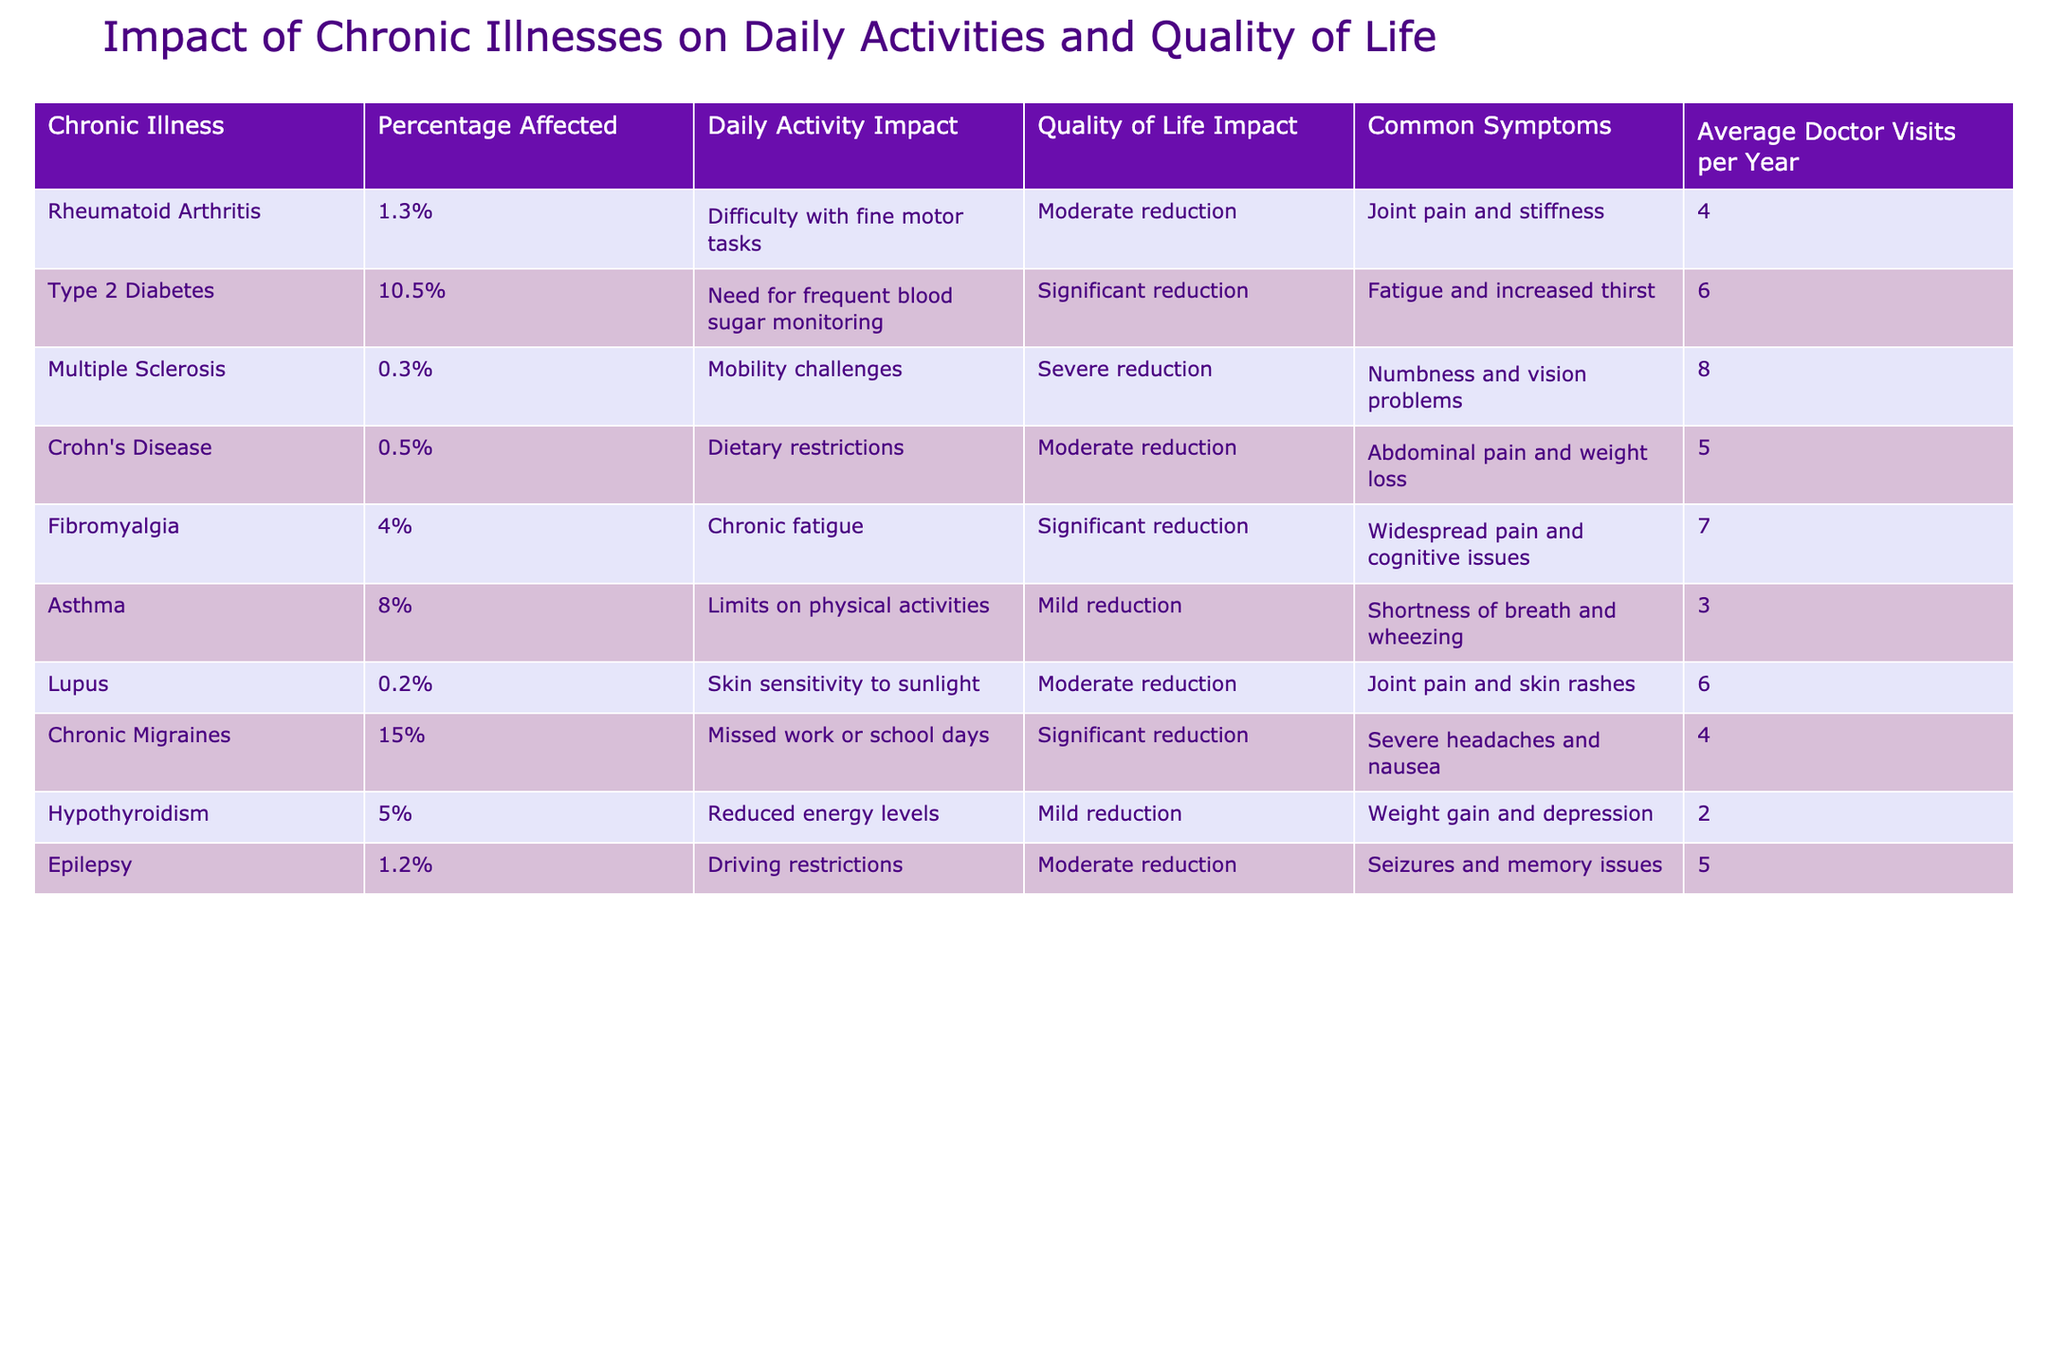What percentage of individuals with chronic migraines experience a significant reduction in quality of life? The table shows that 15% of individuals with chronic migraines are significantly affected in their quality of life.
Answer: 15% Which chronic illness has the lowest percentage affected? The table indicates that lupus has the lowest percentage affected at 0.2%.
Answer: 0.2% How many average doctor visits does a person with Type 2 Diabetes have per year? According to the table, individuals with Type 2 Diabetes make an average of 6 doctor visits per year.
Answer: 6 What is the average daily activity impact for people with Fibromyalgia compared to those with Asthma? Fibromyalgia has a significant reduction, while Asthma has a mild reduction in daily activity impact. Thus, Fibromyalgia has a higher impact.
Answer: Higher impact for Fibromyalgia Does having Epilepsy result in a severe reduction in daily activity? The table shows that Epilepsy results in a moderate reduction in daily activity, so the statement is false.
Answer: False What is the average percentage affected across all chronic illnesses presented in the table? To find the average percentage affected, we sum the percentages: 1.3 + 10.5 + 0.3 + 0.5 + 4 + 8 + 0.2 + 15 + 5 + 1.2 = 42.8%, and then divide by the count of diseases (10), resulting in an average of 4.28%.
Answer: 4.28% What percentage of individuals with Crohn's Disease report a moderate reduction in quality of life? The table states that individuals with Crohn's Disease experience a moderate reduction in quality of life, but it does not specify a percentage, as the overall affected percentage is 0.5%.
Answer: Not specified Which chronic illness causes the most doctor visits per year, and what is that number? The table indicates that Multiple Sclerosis has the most doctor visits at 8 per year.
Answer: 8 Is the impact on daily activities for Lupus higher or lower than for Type 2 Diabetes? Lupus has a moderate reduction while Type 2 Diabetes has a significant reduction. Thus, the impact for Lupus is lower than for Type 2 Diabetes.
Answer: Lower What is the difference in the average number of doctor visits per year between individuals with Rheumatoid Arthritis and those with Asthma? Rheumatoid Arthritis has 4 visits and Asthma has 3 visits. The difference is 4 - 3 = 1 visit per year.
Answer: 1 visit Does the data suggest that Chronic Migraines have a higher impact on daily activities compared to Hypothyroidism? Yes, Chronic Migraines have a significant reduction while Hypothyroidism has a mild reduction, indicating a higher impact for Chronic Migraines.
Answer: Yes 